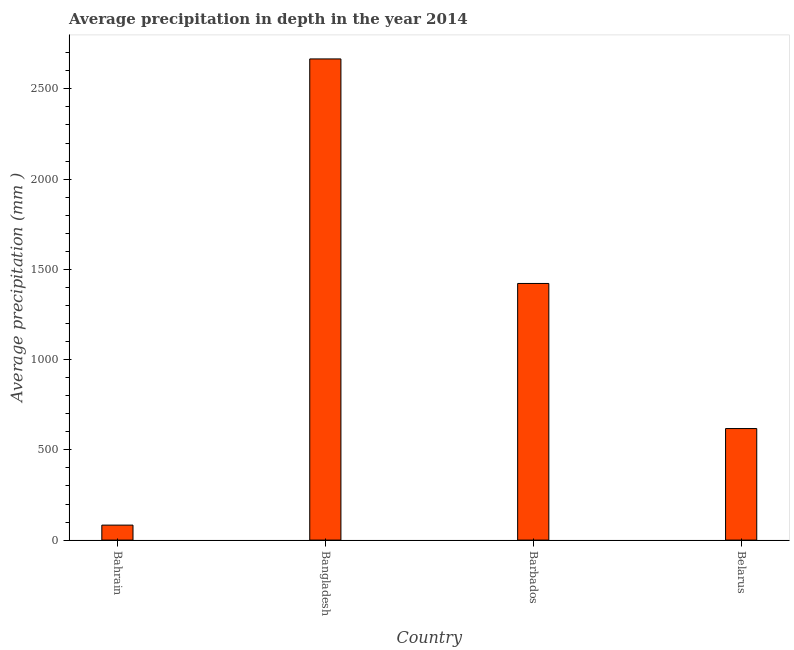Does the graph contain any zero values?
Keep it short and to the point. No. Does the graph contain grids?
Make the answer very short. No. What is the title of the graph?
Offer a terse response. Average precipitation in depth in the year 2014. What is the label or title of the X-axis?
Keep it short and to the point. Country. What is the label or title of the Y-axis?
Offer a very short reply. Average precipitation (mm ). What is the average precipitation in depth in Bangladesh?
Provide a short and direct response. 2666. Across all countries, what is the maximum average precipitation in depth?
Offer a very short reply. 2666. In which country was the average precipitation in depth minimum?
Keep it short and to the point. Bahrain. What is the sum of the average precipitation in depth?
Your answer should be compact. 4789. What is the difference between the average precipitation in depth in Barbados and Belarus?
Offer a terse response. 804. What is the average average precipitation in depth per country?
Ensure brevity in your answer.  1197. What is the median average precipitation in depth?
Your answer should be compact. 1020. What is the ratio of the average precipitation in depth in Bahrain to that in Belarus?
Offer a terse response. 0.13. Is the average precipitation in depth in Bahrain less than that in Belarus?
Your answer should be very brief. Yes. Is the difference between the average precipitation in depth in Barbados and Belarus greater than the difference between any two countries?
Keep it short and to the point. No. What is the difference between the highest and the second highest average precipitation in depth?
Your answer should be compact. 1244. What is the difference between the highest and the lowest average precipitation in depth?
Your answer should be compact. 2583. In how many countries, is the average precipitation in depth greater than the average average precipitation in depth taken over all countries?
Provide a short and direct response. 2. Are all the bars in the graph horizontal?
Make the answer very short. No. What is the difference between two consecutive major ticks on the Y-axis?
Offer a terse response. 500. Are the values on the major ticks of Y-axis written in scientific E-notation?
Offer a very short reply. No. What is the Average precipitation (mm ) of Bangladesh?
Your answer should be compact. 2666. What is the Average precipitation (mm ) of Barbados?
Give a very brief answer. 1422. What is the Average precipitation (mm ) of Belarus?
Make the answer very short. 618. What is the difference between the Average precipitation (mm ) in Bahrain and Bangladesh?
Give a very brief answer. -2583. What is the difference between the Average precipitation (mm ) in Bahrain and Barbados?
Make the answer very short. -1339. What is the difference between the Average precipitation (mm ) in Bahrain and Belarus?
Offer a terse response. -535. What is the difference between the Average precipitation (mm ) in Bangladesh and Barbados?
Your answer should be compact. 1244. What is the difference between the Average precipitation (mm ) in Bangladesh and Belarus?
Your answer should be compact. 2048. What is the difference between the Average precipitation (mm ) in Barbados and Belarus?
Provide a succinct answer. 804. What is the ratio of the Average precipitation (mm ) in Bahrain to that in Bangladesh?
Provide a short and direct response. 0.03. What is the ratio of the Average precipitation (mm ) in Bahrain to that in Barbados?
Offer a very short reply. 0.06. What is the ratio of the Average precipitation (mm ) in Bahrain to that in Belarus?
Offer a very short reply. 0.13. What is the ratio of the Average precipitation (mm ) in Bangladesh to that in Barbados?
Provide a short and direct response. 1.88. What is the ratio of the Average precipitation (mm ) in Bangladesh to that in Belarus?
Make the answer very short. 4.31. What is the ratio of the Average precipitation (mm ) in Barbados to that in Belarus?
Ensure brevity in your answer.  2.3. 